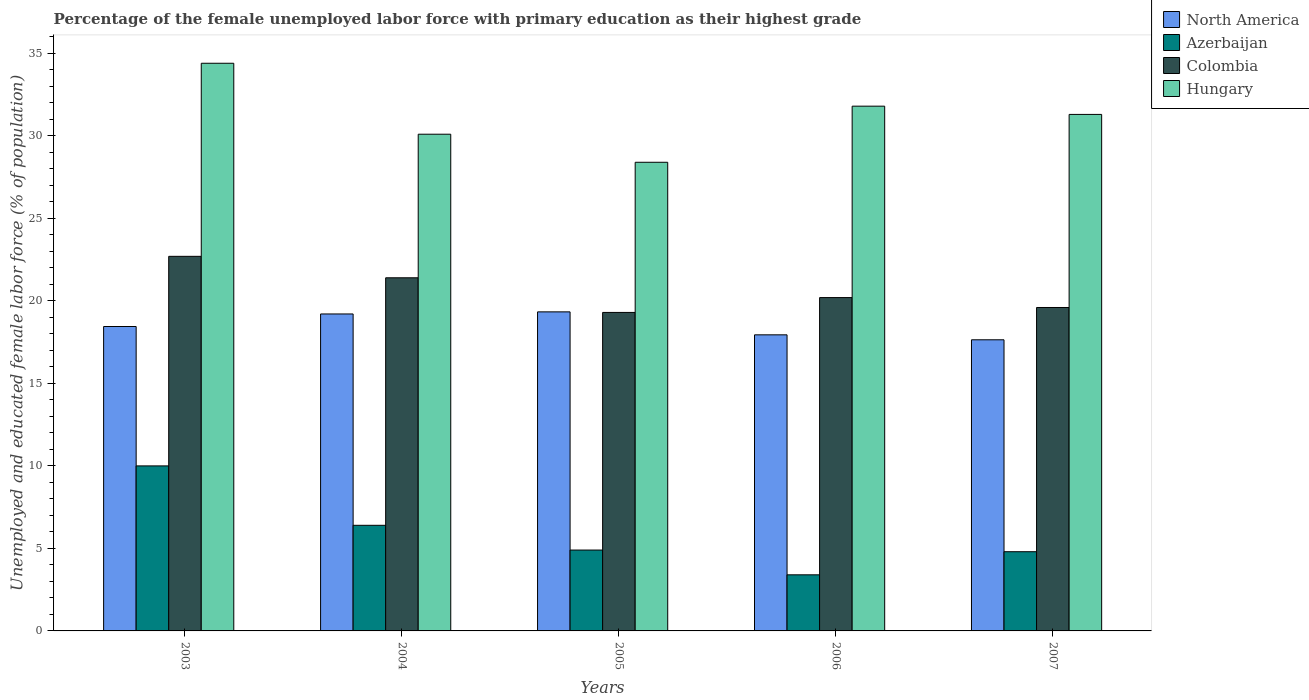Are the number of bars on each tick of the X-axis equal?
Give a very brief answer. Yes. How many bars are there on the 3rd tick from the left?
Offer a terse response. 4. How many bars are there on the 2nd tick from the right?
Make the answer very short. 4. In how many cases, is the number of bars for a given year not equal to the number of legend labels?
Ensure brevity in your answer.  0. What is the percentage of the unemployed female labor force with primary education in North America in 2005?
Give a very brief answer. 19.33. Across all years, what is the maximum percentage of the unemployed female labor force with primary education in North America?
Ensure brevity in your answer.  19.33. Across all years, what is the minimum percentage of the unemployed female labor force with primary education in North America?
Your answer should be compact. 17.64. In which year was the percentage of the unemployed female labor force with primary education in Hungary maximum?
Offer a very short reply. 2003. What is the total percentage of the unemployed female labor force with primary education in Colombia in the graph?
Ensure brevity in your answer.  103.2. What is the difference between the percentage of the unemployed female labor force with primary education in North America in 2003 and that in 2006?
Make the answer very short. 0.5. What is the difference between the percentage of the unemployed female labor force with primary education in Hungary in 2005 and the percentage of the unemployed female labor force with primary education in North America in 2006?
Offer a terse response. 10.46. What is the average percentage of the unemployed female labor force with primary education in North America per year?
Make the answer very short. 18.51. In the year 2005, what is the difference between the percentage of the unemployed female labor force with primary education in Colombia and percentage of the unemployed female labor force with primary education in Azerbaijan?
Provide a succinct answer. 14.4. What is the ratio of the percentage of the unemployed female labor force with primary education in Colombia in 2003 to that in 2005?
Your answer should be very brief. 1.18. Is the difference between the percentage of the unemployed female labor force with primary education in Colombia in 2003 and 2007 greater than the difference between the percentage of the unemployed female labor force with primary education in Azerbaijan in 2003 and 2007?
Ensure brevity in your answer.  No. What is the difference between the highest and the second highest percentage of the unemployed female labor force with primary education in Azerbaijan?
Offer a very short reply. 3.6. What is the difference between the highest and the lowest percentage of the unemployed female labor force with primary education in Colombia?
Offer a terse response. 3.4. In how many years, is the percentage of the unemployed female labor force with primary education in North America greater than the average percentage of the unemployed female labor force with primary education in North America taken over all years?
Provide a short and direct response. 2. What does the 3rd bar from the left in 2003 represents?
Keep it short and to the point. Colombia. What does the 4th bar from the right in 2003 represents?
Keep it short and to the point. North America. Is it the case that in every year, the sum of the percentage of the unemployed female labor force with primary education in North America and percentage of the unemployed female labor force with primary education in Azerbaijan is greater than the percentage of the unemployed female labor force with primary education in Hungary?
Ensure brevity in your answer.  No. Are all the bars in the graph horizontal?
Provide a succinct answer. No. How many years are there in the graph?
Provide a succinct answer. 5. What is the difference between two consecutive major ticks on the Y-axis?
Your answer should be compact. 5. Are the values on the major ticks of Y-axis written in scientific E-notation?
Your answer should be very brief. No. Does the graph contain grids?
Your answer should be very brief. No. How are the legend labels stacked?
Make the answer very short. Vertical. What is the title of the graph?
Provide a succinct answer. Percentage of the female unemployed labor force with primary education as their highest grade. What is the label or title of the Y-axis?
Your answer should be compact. Unemployed and educated female labor force (% of population). What is the Unemployed and educated female labor force (% of population) of North America in 2003?
Make the answer very short. 18.45. What is the Unemployed and educated female labor force (% of population) of Colombia in 2003?
Offer a terse response. 22.7. What is the Unemployed and educated female labor force (% of population) in Hungary in 2003?
Keep it short and to the point. 34.4. What is the Unemployed and educated female labor force (% of population) in North America in 2004?
Your answer should be compact. 19.21. What is the Unemployed and educated female labor force (% of population) in Azerbaijan in 2004?
Ensure brevity in your answer.  6.4. What is the Unemployed and educated female labor force (% of population) in Colombia in 2004?
Make the answer very short. 21.4. What is the Unemployed and educated female labor force (% of population) in Hungary in 2004?
Your answer should be compact. 30.1. What is the Unemployed and educated female labor force (% of population) in North America in 2005?
Your response must be concise. 19.33. What is the Unemployed and educated female labor force (% of population) of Azerbaijan in 2005?
Keep it short and to the point. 4.9. What is the Unemployed and educated female labor force (% of population) of Colombia in 2005?
Your answer should be compact. 19.3. What is the Unemployed and educated female labor force (% of population) of Hungary in 2005?
Offer a terse response. 28.4. What is the Unemployed and educated female labor force (% of population) of North America in 2006?
Give a very brief answer. 17.94. What is the Unemployed and educated female labor force (% of population) in Azerbaijan in 2006?
Provide a short and direct response. 3.4. What is the Unemployed and educated female labor force (% of population) of Colombia in 2006?
Provide a succinct answer. 20.2. What is the Unemployed and educated female labor force (% of population) in Hungary in 2006?
Make the answer very short. 31.8. What is the Unemployed and educated female labor force (% of population) in North America in 2007?
Provide a succinct answer. 17.64. What is the Unemployed and educated female labor force (% of population) in Azerbaijan in 2007?
Your response must be concise. 4.8. What is the Unemployed and educated female labor force (% of population) of Colombia in 2007?
Keep it short and to the point. 19.6. What is the Unemployed and educated female labor force (% of population) of Hungary in 2007?
Make the answer very short. 31.3. Across all years, what is the maximum Unemployed and educated female labor force (% of population) in North America?
Provide a succinct answer. 19.33. Across all years, what is the maximum Unemployed and educated female labor force (% of population) in Azerbaijan?
Provide a succinct answer. 10. Across all years, what is the maximum Unemployed and educated female labor force (% of population) in Colombia?
Your response must be concise. 22.7. Across all years, what is the maximum Unemployed and educated female labor force (% of population) in Hungary?
Offer a terse response. 34.4. Across all years, what is the minimum Unemployed and educated female labor force (% of population) in North America?
Give a very brief answer. 17.64. Across all years, what is the minimum Unemployed and educated female labor force (% of population) of Azerbaijan?
Provide a succinct answer. 3.4. Across all years, what is the minimum Unemployed and educated female labor force (% of population) in Colombia?
Provide a short and direct response. 19.3. Across all years, what is the minimum Unemployed and educated female labor force (% of population) of Hungary?
Offer a terse response. 28.4. What is the total Unemployed and educated female labor force (% of population) in North America in the graph?
Make the answer very short. 92.57. What is the total Unemployed and educated female labor force (% of population) in Azerbaijan in the graph?
Your answer should be very brief. 29.5. What is the total Unemployed and educated female labor force (% of population) of Colombia in the graph?
Provide a short and direct response. 103.2. What is the total Unemployed and educated female labor force (% of population) of Hungary in the graph?
Give a very brief answer. 156. What is the difference between the Unemployed and educated female labor force (% of population) in North America in 2003 and that in 2004?
Ensure brevity in your answer.  -0.76. What is the difference between the Unemployed and educated female labor force (% of population) of Hungary in 2003 and that in 2004?
Provide a succinct answer. 4.3. What is the difference between the Unemployed and educated female labor force (% of population) in North America in 2003 and that in 2005?
Provide a succinct answer. -0.89. What is the difference between the Unemployed and educated female labor force (% of population) in Azerbaijan in 2003 and that in 2005?
Offer a terse response. 5.1. What is the difference between the Unemployed and educated female labor force (% of population) in Colombia in 2003 and that in 2005?
Offer a terse response. 3.4. What is the difference between the Unemployed and educated female labor force (% of population) of Hungary in 2003 and that in 2005?
Offer a very short reply. 6. What is the difference between the Unemployed and educated female labor force (% of population) of North America in 2003 and that in 2006?
Make the answer very short. 0.5. What is the difference between the Unemployed and educated female labor force (% of population) in Azerbaijan in 2003 and that in 2006?
Provide a succinct answer. 6.6. What is the difference between the Unemployed and educated female labor force (% of population) in Hungary in 2003 and that in 2006?
Provide a succinct answer. 2.6. What is the difference between the Unemployed and educated female labor force (% of population) in North America in 2003 and that in 2007?
Provide a short and direct response. 0.8. What is the difference between the Unemployed and educated female labor force (% of population) of Colombia in 2003 and that in 2007?
Make the answer very short. 3.1. What is the difference between the Unemployed and educated female labor force (% of population) of North America in 2004 and that in 2005?
Provide a succinct answer. -0.13. What is the difference between the Unemployed and educated female labor force (% of population) in Azerbaijan in 2004 and that in 2005?
Offer a very short reply. 1.5. What is the difference between the Unemployed and educated female labor force (% of population) in North America in 2004 and that in 2006?
Provide a short and direct response. 1.26. What is the difference between the Unemployed and educated female labor force (% of population) of Azerbaijan in 2004 and that in 2006?
Your answer should be very brief. 3. What is the difference between the Unemployed and educated female labor force (% of population) of Colombia in 2004 and that in 2006?
Offer a very short reply. 1.2. What is the difference between the Unemployed and educated female labor force (% of population) of North America in 2004 and that in 2007?
Offer a terse response. 1.56. What is the difference between the Unemployed and educated female labor force (% of population) of Azerbaijan in 2004 and that in 2007?
Provide a succinct answer. 1.6. What is the difference between the Unemployed and educated female labor force (% of population) of Colombia in 2004 and that in 2007?
Your answer should be compact. 1.8. What is the difference between the Unemployed and educated female labor force (% of population) of North America in 2005 and that in 2006?
Provide a short and direct response. 1.39. What is the difference between the Unemployed and educated female labor force (% of population) of Azerbaijan in 2005 and that in 2006?
Keep it short and to the point. 1.5. What is the difference between the Unemployed and educated female labor force (% of population) in Colombia in 2005 and that in 2006?
Provide a short and direct response. -0.9. What is the difference between the Unemployed and educated female labor force (% of population) in North America in 2005 and that in 2007?
Make the answer very short. 1.69. What is the difference between the Unemployed and educated female labor force (% of population) of Azerbaijan in 2005 and that in 2007?
Your answer should be compact. 0.1. What is the difference between the Unemployed and educated female labor force (% of population) in Colombia in 2005 and that in 2007?
Ensure brevity in your answer.  -0.3. What is the difference between the Unemployed and educated female labor force (% of population) of Hungary in 2005 and that in 2007?
Your response must be concise. -2.9. What is the difference between the Unemployed and educated female labor force (% of population) of North America in 2006 and that in 2007?
Offer a terse response. 0.3. What is the difference between the Unemployed and educated female labor force (% of population) in Hungary in 2006 and that in 2007?
Give a very brief answer. 0.5. What is the difference between the Unemployed and educated female labor force (% of population) of North America in 2003 and the Unemployed and educated female labor force (% of population) of Azerbaijan in 2004?
Your answer should be very brief. 12.05. What is the difference between the Unemployed and educated female labor force (% of population) of North America in 2003 and the Unemployed and educated female labor force (% of population) of Colombia in 2004?
Keep it short and to the point. -2.95. What is the difference between the Unemployed and educated female labor force (% of population) in North America in 2003 and the Unemployed and educated female labor force (% of population) in Hungary in 2004?
Give a very brief answer. -11.65. What is the difference between the Unemployed and educated female labor force (% of population) of Azerbaijan in 2003 and the Unemployed and educated female labor force (% of population) of Colombia in 2004?
Keep it short and to the point. -11.4. What is the difference between the Unemployed and educated female labor force (% of population) of Azerbaijan in 2003 and the Unemployed and educated female labor force (% of population) of Hungary in 2004?
Provide a short and direct response. -20.1. What is the difference between the Unemployed and educated female labor force (% of population) in North America in 2003 and the Unemployed and educated female labor force (% of population) in Azerbaijan in 2005?
Keep it short and to the point. 13.55. What is the difference between the Unemployed and educated female labor force (% of population) in North America in 2003 and the Unemployed and educated female labor force (% of population) in Colombia in 2005?
Provide a succinct answer. -0.85. What is the difference between the Unemployed and educated female labor force (% of population) of North America in 2003 and the Unemployed and educated female labor force (% of population) of Hungary in 2005?
Your answer should be very brief. -9.95. What is the difference between the Unemployed and educated female labor force (% of population) of Azerbaijan in 2003 and the Unemployed and educated female labor force (% of population) of Hungary in 2005?
Offer a very short reply. -18.4. What is the difference between the Unemployed and educated female labor force (% of population) of Colombia in 2003 and the Unemployed and educated female labor force (% of population) of Hungary in 2005?
Provide a short and direct response. -5.7. What is the difference between the Unemployed and educated female labor force (% of population) of North America in 2003 and the Unemployed and educated female labor force (% of population) of Azerbaijan in 2006?
Give a very brief answer. 15.05. What is the difference between the Unemployed and educated female labor force (% of population) of North America in 2003 and the Unemployed and educated female labor force (% of population) of Colombia in 2006?
Make the answer very short. -1.75. What is the difference between the Unemployed and educated female labor force (% of population) of North America in 2003 and the Unemployed and educated female labor force (% of population) of Hungary in 2006?
Ensure brevity in your answer.  -13.35. What is the difference between the Unemployed and educated female labor force (% of population) of Azerbaijan in 2003 and the Unemployed and educated female labor force (% of population) of Hungary in 2006?
Offer a terse response. -21.8. What is the difference between the Unemployed and educated female labor force (% of population) of Colombia in 2003 and the Unemployed and educated female labor force (% of population) of Hungary in 2006?
Offer a very short reply. -9.1. What is the difference between the Unemployed and educated female labor force (% of population) of North America in 2003 and the Unemployed and educated female labor force (% of population) of Azerbaijan in 2007?
Ensure brevity in your answer.  13.65. What is the difference between the Unemployed and educated female labor force (% of population) in North America in 2003 and the Unemployed and educated female labor force (% of population) in Colombia in 2007?
Provide a succinct answer. -1.15. What is the difference between the Unemployed and educated female labor force (% of population) in North America in 2003 and the Unemployed and educated female labor force (% of population) in Hungary in 2007?
Offer a terse response. -12.85. What is the difference between the Unemployed and educated female labor force (% of population) in Azerbaijan in 2003 and the Unemployed and educated female labor force (% of population) in Hungary in 2007?
Provide a short and direct response. -21.3. What is the difference between the Unemployed and educated female labor force (% of population) of Colombia in 2003 and the Unemployed and educated female labor force (% of population) of Hungary in 2007?
Your answer should be very brief. -8.6. What is the difference between the Unemployed and educated female labor force (% of population) of North America in 2004 and the Unemployed and educated female labor force (% of population) of Azerbaijan in 2005?
Give a very brief answer. 14.31. What is the difference between the Unemployed and educated female labor force (% of population) of North America in 2004 and the Unemployed and educated female labor force (% of population) of Colombia in 2005?
Your answer should be very brief. -0.09. What is the difference between the Unemployed and educated female labor force (% of population) in North America in 2004 and the Unemployed and educated female labor force (% of population) in Hungary in 2005?
Keep it short and to the point. -9.19. What is the difference between the Unemployed and educated female labor force (% of population) in Azerbaijan in 2004 and the Unemployed and educated female labor force (% of population) in Colombia in 2005?
Provide a succinct answer. -12.9. What is the difference between the Unemployed and educated female labor force (% of population) of North America in 2004 and the Unemployed and educated female labor force (% of population) of Azerbaijan in 2006?
Keep it short and to the point. 15.81. What is the difference between the Unemployed and educated female labor force (% of population) of North America in 2004 and the Unemployed and educated female labor force (% of population) of Colombia in 2006?
Provide a short and direct response. -0.99. What is the difference between the Unemployed and educated female labor force (% of population) in North America in 2004 and the Unemployed and educated female labor force (% of population) in Hungary in 2006?
Keep it short and to the point. -12.59. What is the difference between the Unemployed and educated female labor force (% of population) of Azerbaijan in 2004 and the Unemployed and educated female labor force (% of population) of Hungary in 2006?
Your answer should be very brief. -25.4. What is the difference between the Unemployed and educated female labor force (% of population) in Colombia in 2004 and the Unemployed and educated female labor force (% of population) in Hungary in 2006?
Offer a terse response. -10.4. What is the difference between the Unemployed and educated female labor force (% of population) in North America in 2004 and the Unemployed and educated female labor force (% of population) in Azerbaijan in 2007?
Offer a very short reply. 14.41. What is the difference between the Unemployed and educated female labor force (% of population) of North America in 2004 and the Unemployed and educated female labor force (% of population) of Colombia in 2007?
Your answer should be compact. -0.39. What is the difference between the Unemployed and educated female labor force (% of population) in North America in 2004 and the Unemployed and educated female labor force (% of population) in Hungary in 2007?
Keep it short and to the point. -12.09. What is the difference between the Unemployed and educated female labor force (% of population) in Azerbaijan in 2004 and the Unemployed and educated female labor force (% of population) in Colombia in 2007?
Offer a terse response. -13.2. What is the difference between the Unemployed and educated female labor force (% of population) in Azerbaijan in 2004 and the Unemployed and educated female labor force (% of population) in Hungary in 2007?
Give a very brief answer. -24.9. What is the difference between the Unemployed and educated female labor force (% of population) in North America in 2005 and the Unemployed and educated female labor force (% of population) in Azerbaijan in 2006?
Provide a short and direct response. 15.93. What is the difference between the Unemployed and educated female labor force (% of population) in North America in 2005 and the Unemployed and educated female labor force (% of population) in Colombia in 2006?
Your response must be concise. -0.87. What is the difference between the Unemployed and educated female labor force (% of population) of North America in 2005 and the Unemployed and educated female labor force (% of population) of Hungary in 2006?
Provide a short and direct response. -12.47. What is the difference between the Unemployed and educated female labor force (% of population) of Azerbaijan in 2005 and the Unemployed and educated female labor force (% of population) of Colombia in 2006?
Your response must be concise. -15.3. What is the difference between the Unemployed and educated female labor force (% of population) in Azerbaijan in 2005 and the Unemployed and educated female labor force (% of population) in Hungary in 2006?
Your answer should be compact. -26.9. What is the difference between the Unemployed and educated female labor force (% of population) in Colombia in 2005 and the Unemployed and educated female labor force (% of population) in Hungary in 2006?
Your answer should be compact. -12.5. What is the difference between the Unemployed and educated female labor force (% of population) in North America in 2005 and the Unemployed and educated female labor force (% of population) in Azerbaijan in 2007?
Provide a short and direct response. 14.53. What is the difference between the Unemployed and educated female labor force (% of population) of North America in 2005 and the Unemployed and educated female labor force (% of population) of Colombia in 2007?
Give a very brief answer. -0.27. What is the difference between the Unemployed and educated female labor force (% of population) in North America in 2005 and the Unemployed and educated female labor force (% of population) in Hungary in 2007?
Your response must be concise. -11.97. What is the difference between the Unemployed and educated female labor force (% of population) in Azerbaijan in 2005 and the Unemployed and educated female labor force (% of population) in Colombia in 2007?
Keep it short and to the point. -14.7. What is the difference between the Unemployed and educated female labor force (% of population) in Azerbaijan in 2005 and the Unemployed and educated female labor force (% of population) in Hungary in 2007?
Your answer should be very brief. -26.4. What is the difference between the Unemployed and educated female labor force (% of population) of North America in 2006 and the Unemployed and educated female labor force (% of population) of Azerbaijan in 2007?
Ensure brevity in your answer.  13.14. What is the difference between the Unemployed and educated female labor force (% of population) in North America in 2006 and the Unemployed and educated female labor force (% of population) in Colombia in 2007?
Offer a terse response. -1.66. What is the difference between the Unemployed and educated female labor force (% of population) in North America in 2006 and the Unemployed and educated female labor force (% of population) in Hungary in 2007?
Provide a succinct answer. -13.36. What is the difference between the Unemployed and educated female labor force (% of population) in Azerbaijan in 2006 and the Unemployed and educated female labor force (% of population) in Colombia in 2007?
Provide a short and direct response. -16.2. What is the difference between the Unemployed and educated female labor force (% of population) of Azerbaijan in 2006 and the Unemployed and educated female labor force (% of population) of Hungary in 2007?
Ensure brevity in your answer.  -27.9. What is the difference between the Unemployed and educated female labor force (% of population) in Colombia in 2006 and the Unemployed and educated female labor force (% of population) in Hungary in 2007?
Offer a terse response. -11.1. What is the average Unemployed and educated female labor force (% of population) in North America per year?
Offer a very short reply. 18.52. What is the average Unemployed and educated female labor force (% of population) of Colombia per year?
Offer a very short reply. 20.64. What is the average Unemployed and educated female labor force (% of population) in Hungary per year?
Offer a terse response. 31.2. In the year 2003, what is the difference between the Unemployed and educated female labor force (% of population) of North America and Unemployed and educated female labor force (% of population) of Azerbaijan?
Provide a succinct answer. 8.45. In the year 2003, what is the difference between the Unemployed and educated female labor force (% of population) of North America and Unemployed and educated female labor force (% of population) of Colombia?
Give a very brief answer. -4.25. In the year 2003, what is the difference between the Unemployed and educated female labor force (% of population) of North America and Unemployed and educated female labor force (% of population) of Hungary?
Give a very brief answer. -15.95. In the year 2003, what is the difference between the Unemployed and educated female labor force (% of population) in Azerbaijan and Unemployed and educated female labor force (% of population) in Colombia?
Your answer should be very brief. -12.7. In the year 2003, what is the difference between the Unemployed and educated female labor force (% of population) of Azerbaijan and Unemployed and educated female labor force (% of population) of Hungary?
Offer a very short reply. -24.4. In the year 2004, what is the difference between the Unemployed and educated female labor force (% of population) in North America and Unemployed and educated female labor force (% of population) in Azerbaijan?
Ensure brevity in your answer.  12.81. In the year 2004, what is the difference between the Unemployed and educated female labor force (% of population) in North America and Unemployed and educated female labor force (% of population) in Colombia?
Offer a very short reply. -2.19. In the year 2004, what is the difference between the Unemployed and educated female labor force (% of population) of North America and Unemployed and educated female labor force (% of population) of Hungary?
Ensure brevity in your answer.  -10.89. In the year 2004, what is the difference between the Unemployed and educated female labor force (% of population) in Azerbaijan and Unemployed and educated female labor force (% of population) in Colombia?
Your answer should be compact. -15. In the year 2004, what is the difference between the Unemployed and educated female labor force (% of population) in Azerbaijan and Unemployed and educated female labor force (% of population) in Hungary?
Offer a very short reply. -23.7. In the year 2005, what is the difference between the Unemployed and educated female labor force (% of population) of North America and Unemployed and educated female labor force (% of population) of Azerbaijan?
Keep it short and to the point. 14.43. In the year 2005, what is the difference between the Unemployed and educated female labor force (% of population) in North America and Unemployed and educated female labor force (% of population) in Colombia?
Keep it short and to the point. 0.03. In the year 2005, what is the difference between the Unemployed and educated female labor force (% of population) of North America and Unemployed and educated female labor force (% of population) of Hungary?
Your answer should be compact. -9.07. In the year 2005, what is the difference between the Unemployed and educated female labor force (% of population) in Azerbaijan and Unemployed and educated female labor force (% of population) in Colombia?
Ensure brevity in your answer.  -14.4. In the year 2005, what is the difference between the Unemployed and educated female labor force (% of population) in Azerbaijan and Unemployed and educated female labor force (% of population) in Hungary?
Provide a succinct answer. -23.5. In the year 2006, what is the difference between the Unemployed and educated female labor force (% of population) in North America and Unemployed and educated female labor force (% of population) in Azerbaijan?
Give a very brief answer. 14.54. In the year 2006, what is the difference between the Unemployed and educated female labor force (% of population) of North America and Unemployed and educated female labor force (% of population) of Colombia?
Offer a very short reply. -2.26. In the year 2006, what is the difference between the Unemployed and educated female labor force (% of population) in North America and Unemployed and educated female labor force (% of population) in Hungary?
Give a very brief answer. -13.86. In the year 2006, what is the difference between the Unemployed and educated female labor force (% of population) in Azerbaijan and Unemployed and educated female labor force (% of population) in Colombia?
Provide a succinct answer. -16.8. In the year 2006, what is the difference between the Unemployed and educated female labor force (% of population) of Azerbaijan and Unemployed and educated female labor force (% of population) of Hungary?
Ensure brevity in your answer.  -28.4. In the year 2007, what is the difference between the Unemployed and educated female labor force (% of population) in North America and Unemployed and educated female labor force (% of population) in Azerbaijan?
Give a very brief answer. 12.84. In the year 2007, what is the difference between the Unemployed and educated female labor force (% of population) of North America and Unemployed and educated female labor force (% of population) of Colombia?
Make the answer very short. -1.96. In the year 2007, what is the difference between the Unemployed and educated female labor force (% of population) in North America and Unemployed and educated female labor force (% of population) in Hungary?
Provide a succinct answer. -13.66. In the year 2007, what is the difference between the Unemployed and educated female labor force (% of population) of Azerbaijan and Unemployed and educated female labor force (% of population) of Colombia?
Your response must be concise. -14.8. In the year 2007, what is the difference between the Unemployed and educated female labor force (% of population) of Azerbaijan and Unemployed and educated female labor force (% of population) of Hungary?
Your answer should be compact. -26.5. In the year 2007, what is the difference between the Unemployed and educated female labor force (% of population) of Colombia and Unemployed and educated female labor force (% of population) of Hungary?
Provide a short and direct response. -11.7. What is the ratio of the Unemployed and educated female labor force (% of population) of North America in 2003 to that in 2004?
Ensure brevity in your answer.  0.96. What is the ratio of the Unemployed and educated female labor force (% of population) in Azerbaijan in 2003 to that in 2004?
Give a very brief answer. 1.56. What is the ratio of the Unemployed and educated female labor force (% of population) in Colombia in 2003 to that in 2004?
Offer a very short reply. 1.06. What is the ratio of the Unemployed and educated female labor force (% of population) in North America in 2003 to that in 2005?
Provide a short and direct response. 0.95. What is the ratio of the Unemployed and educated female labor force (% of population) of Azerbaijan in 2003 to that in 2005?
Your answer should be very brief. 2.04. What is the ratio of the Unemployed and educated female labor force (% of population) in Colombia in 2003 to that in 2005?
Make the answer very short. 1.18. What is the ratio of the Unemployed and educated female labor force (% of population) in Hungary in 2003 to that in 2005?
Offer a very short reply. 1.21. What is the ratio of the Unemployed and educated female labor force (% of population) of North America in 2003 to that in 2006?
Keep it short and to the point. 1.03. What is the ratio of the Unemployed and educated female labor force (% of population) in Azerbaijan in 2003 to that in 2006?
Your response must be concise. 2.94. What is the ratio of the Unemployed and educated female labor force (% of population) of Colombia in 2003 to that in 2006?
Keep it short and to the point. 1.12. What is the ratio of the Unemployed and educated female labor force (% of population) in Hungary in 2003 to that in 2006?
Your response must be concise. 1.08. What is the ratio of the Unemployed and educated female labor force (% of population) of North America in 2003 to that in 2007?
Your answer should be very brief. 1.05. What is the ratio of the Unemployed and educated female labor force (% of population) in Azerbaijan in 2003 to that in 2007?
Make the answer very short. 2.08. What is the ratio of the Unemployed and educated female labor force (% of population) of Colombia in 2003 to that in 2007?
Give a very brief answer. 1.16. What is the ratio of the Unemployed and educated female labor force (% of population) in Hungary in 2003 to that in 2007?
Provide a short and direct response. 1.1. What is the ratio of the Unemployed and educated female labor force (% of population) of North America in 2004 to that in 2005?
Your response must be concise. 0.99. What is the ratio of the Unemployed and educated female labor force (% of population) of Azerbaijan in 2004 to that in 2005?
Give a very brief answer. 1.31. What is the ratio of the Unemployed and educated female labor force (% of population) of Colombia in 2004 to that in 2005?
Ensure brevity in your answer.  1.11. What is the ratio of the Unemployed and educated female labor force (% of population) of Hungary in 2004 to that in 2005?
Provide a short and direct response. 1.06. What is the ratio of the Unemployed and educated female labor force (% of population) of North America in 2004 to that in 2006?
Your answer should be compact. 1.07. What is the ratio of the Unemployed and educated female labor force (% of population) of Azerbaijan in 2004 to that in 2006?
Your answer should be compact. 1.88. What is the ratio of the Unemployed and educated female labor force (% of population) in Colombia in 2004 to that in 2006?
Keep it short and to the point. 1.06. What is the ratio of the Unemployed and educated female labor force (% of population) in Hungary in 2004 to that in 2006?
Your response must be concise. 0.95. What is the ratio of the Unemployed and educated female labor force (% of population) of North America in 2004 to that in 2007?
Provide a succinct answer. 1.09. What is the ratio of the Unemployed and educated female labor force (% of population) of Colombia in 2004 to that in 2007?
Keep it short and to the point. 1.09. What is the ratio of the Unemployed and educated female labor force (% of population) of Hungary in 2004 to that in 2007?
Offer a very short reply. 0.96. What is the ratio of the Unemployed and educated female labor force (% of population) in North America in 2005 to that in 2006?
Your answer should be compact. 1.08. What is the ratio of the Unemployed and educated female labor force (% of population) of Azerbaijan in 2005 to that in 2006?
Give a very brief answer. 1.44. What is the ratio of the Unemployed and educated female labor force (% of population) of Colombia in 2005 to that in 2006?
Your response must be concise. 0.96. What is the ratio of the Unemployed and educated female labor force (% of population) in Hungary in 2005 to that in 2006?
Your answer should be very brief. 0.89. What is the ratio of the Unemployed and educated female labor force (% of population) of North America in 2005 to that in 2007?
Ensure brevity in your answer.  1.1. What is the ratio of the Unemployed and educated female labor force (% of population) of Azerbaijan in 2005 to that in 2007?
Offer a terse response. 1.02. What is the ratio of the Unemployed and educated female labor force (% of population) of Colombia in 2005 to that in 2007?
Provide a succinct answer. 0.98. What is the ratio of the Unemployed and educated female labor force (% of population) of Hungary in 2005 to that in 2007?
Your answer should be compact. 0.91. What is the ratio of the Unemployed and educated female labor force (% of population) in North America in 2006 to that in 2007?
Your response must be concise. 1.02. What is the ratio of the Unemployed and educated female labor force (% of population) of Azerbaijan in 2006 to that in 2007?
Provide a short and direct response. 0.71. What is the ratio of the Unemployed and educated female labor force (% of population) in Colombia in 2006 to that in 2007?
Give a very brief answer. 1.03. What is the ratio of the Unemployed and educated female labor force (% of population) in Hungary in 2006 to that in 2007?
Ensure brevity in your answer.  1.02. What is the difference between the highest and the second highest Unemployed and educated female labor force (% of population) in North America?
Provide a short and direct response. 0.13. What is the difference between the highest and the second highest Unemployed and educated female labor force (% of population) in Hungary?
Ensure brevity in your answer.  2.6. What is the difference between the highest and the lowest Unemployed and educated female labor force (% of population) in North America?
Offer a terse response. 1.69. What is the difference between the highest and the lowest Unemployed and educated female labor force (% of population) in Azerbaijan?
Keep it short and to the point. 6.6. What is the difference between the highest and the lowest Unemployed and educated female labor force (% of population) of Colombia?
Offer a terse response. 3.4. 